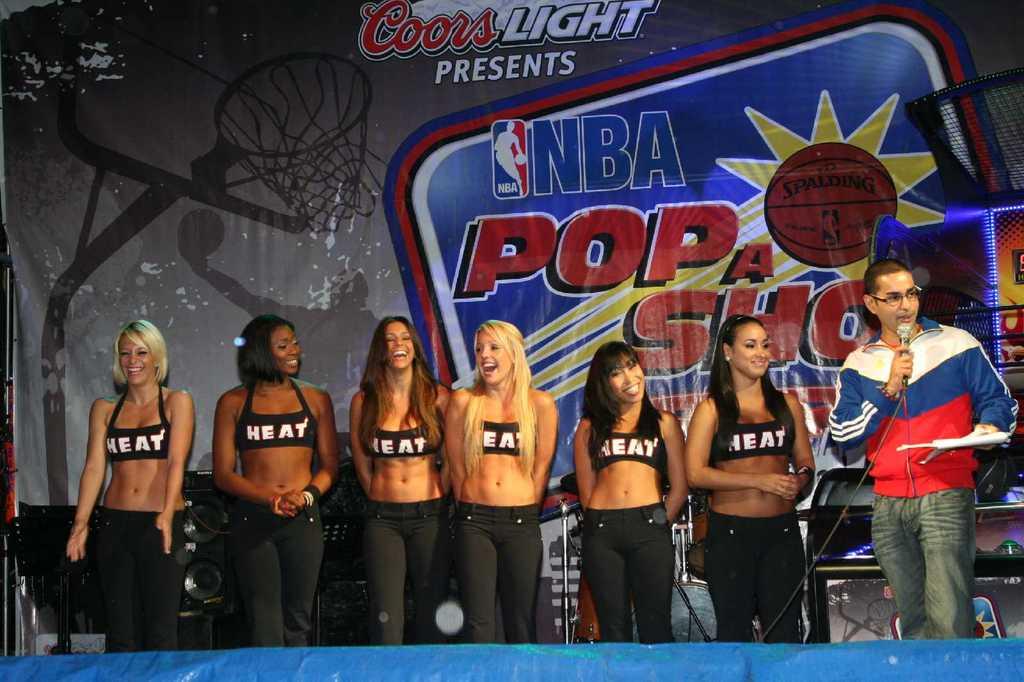What sports league do the cheerleaders represent?
Offer a terse response. Nba. What team are they representing?
Ensure brevity in your answer.  Heat. 